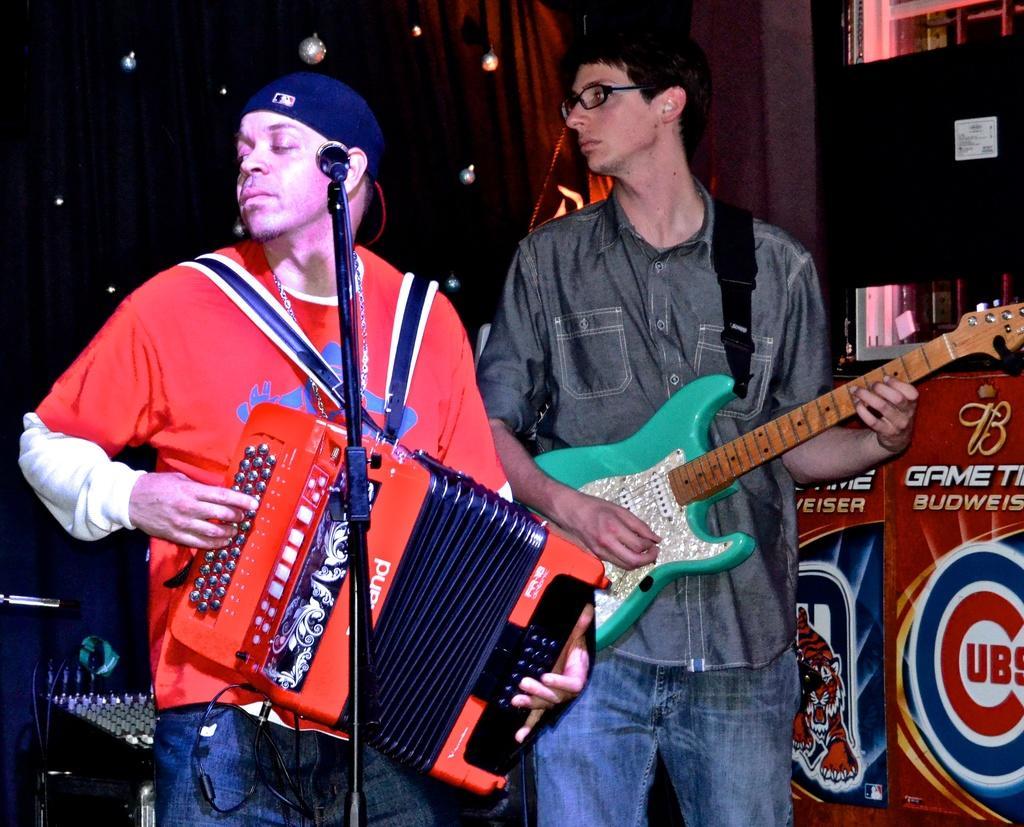How would you summarize this image in a sentence or two? There are two men standing and playing musical instruments,in front of this man we can see microphone with stand. We can see posters. In the background we can see curtains,device and lights. 